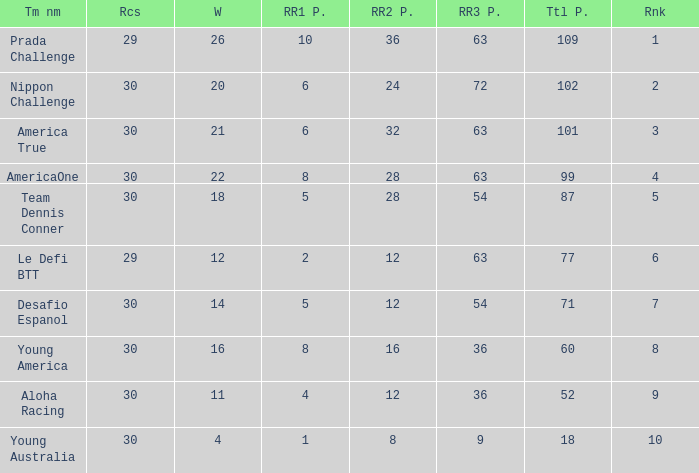Name the races for the prada challenge 29.0. 